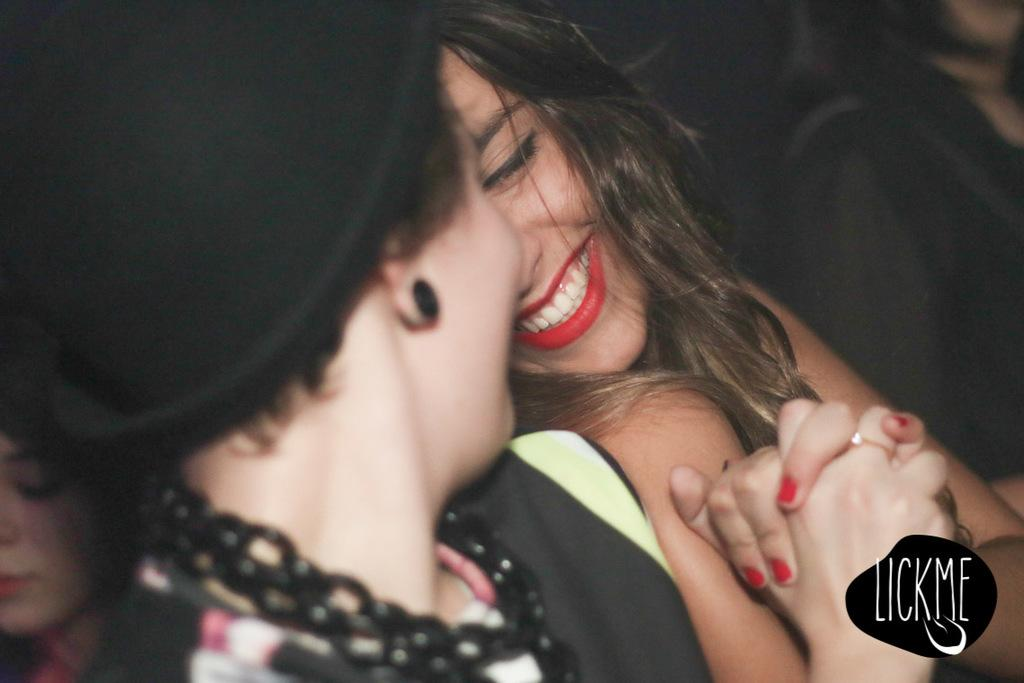How many people are present in the image? There are four persons in the image. Can you describe any additional features of the image? Yes, there is a watermark on the image. How many trees can be seen in the image? There are no trees visible in the image. What type of patch is present on the person's clothing in the image? There is no patch visible on anyone's clothing in the image. 